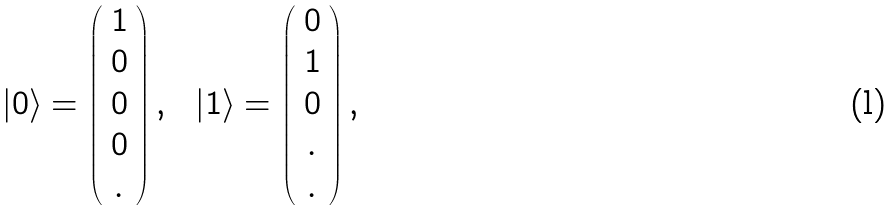Convert formula to latex. <formula><loc_0><loc_0><loc_500><loc_500>| 0 \rangle = \left ( \begin{array} { c } 1 \\ 0 \\ 0 \\ 0 \\ . \end{array} \right ) , \ \ | 1 \rangle = \left ( \begin{array} { c } 0 \\ 1 \\ 0 \\ . \\ . \end{array} \right ) ,</formula> 